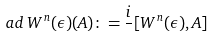<formula> <loc_0><loc_0><loc_500><loc_500>a d \, W ^ { n } ( \epsilon ) ( A ) \colon = \frac { i } { } [ W ^ { n } ( \epsilon ) , A ]</formula> 